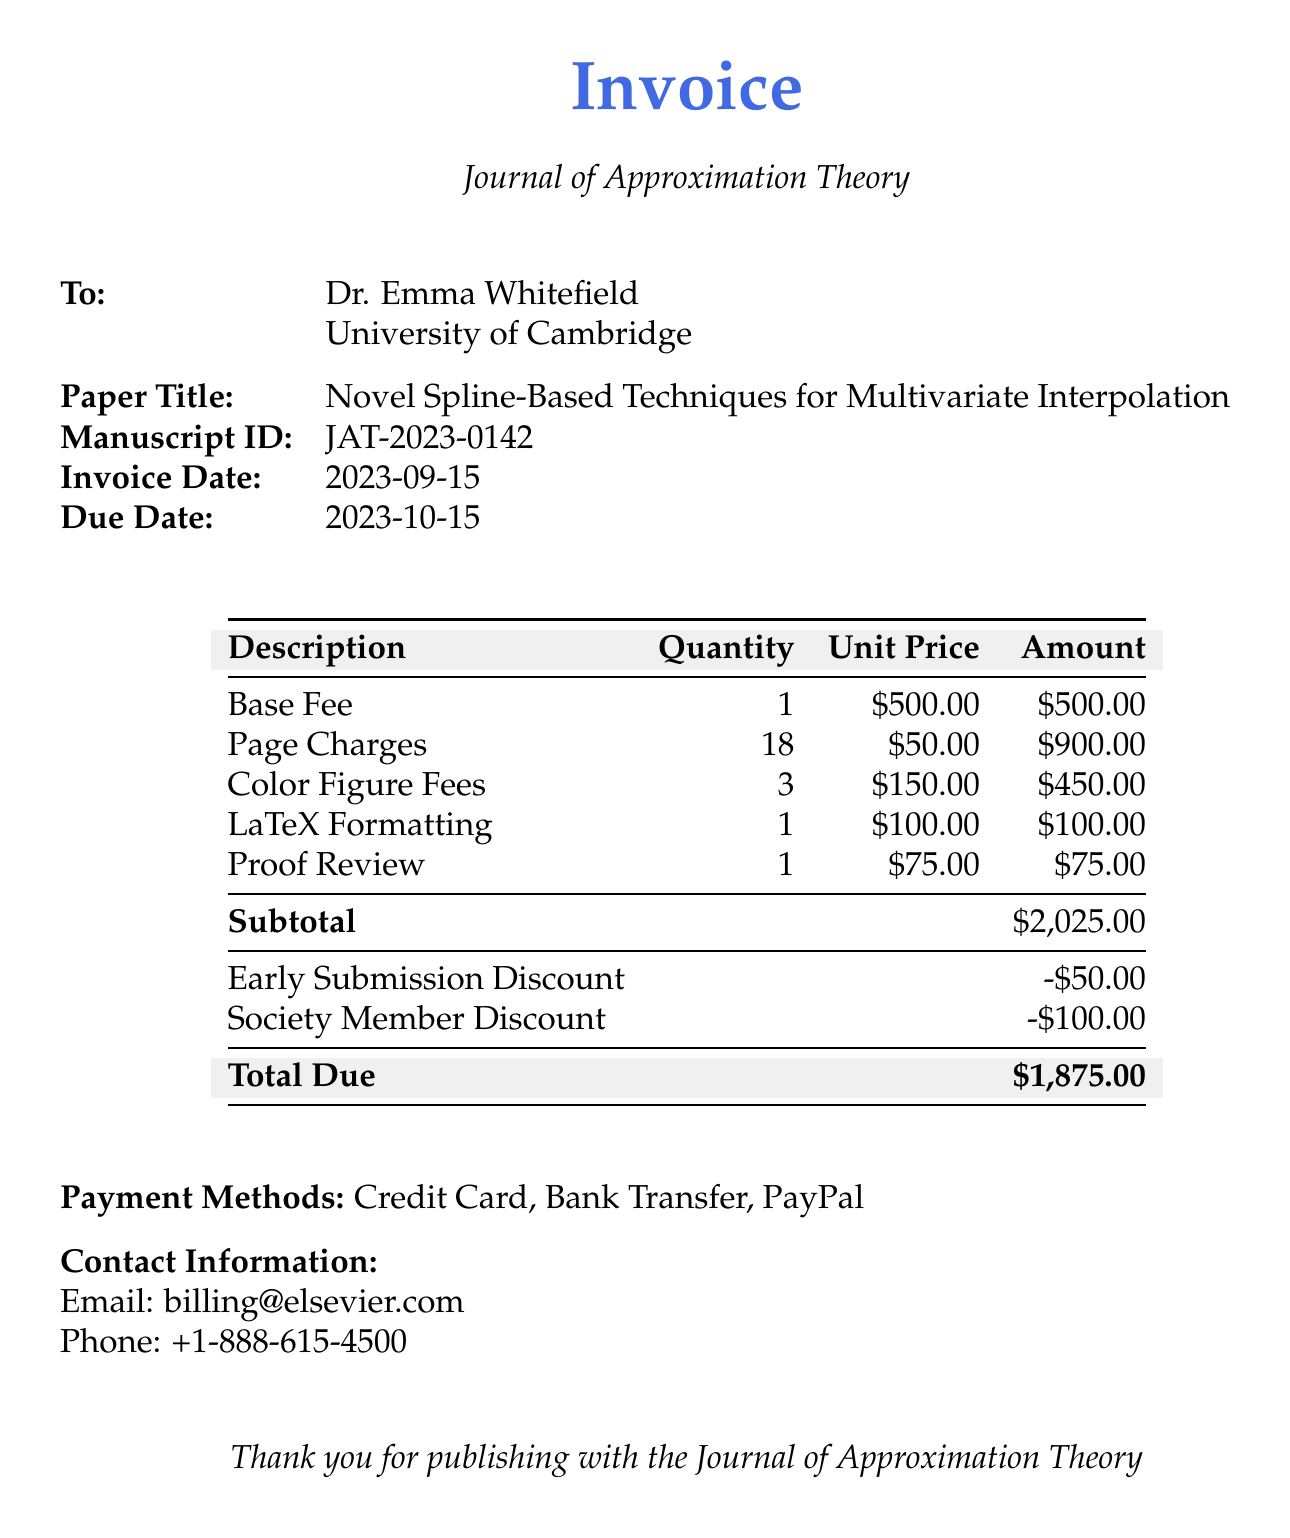What is the title of the paper? The title of the paper is listed in the invoice under "Paper Title".
Answer: Novel Spline-Based Techniques for Multivariate Interpolation What is the manuscript ID? The manuscript ID can be found among the details of the invoice.
Answer: JAT-2023-0142 What is the invoice date? The invoice date is specified in the document.
Answer: 2023-09-15 What is the total due amount? The total due amount appears at the end of the invoice in the "Total Due" section.
Answer: $1,875.00 How many color figures are included in the charges? The number of color figures charged is detailed in the table under "Color Figure Fees".
Answer: 3 What is the subtotal amount before discounts? The subtotal is given just before any discounts are applied in the invoice.
Answer: $2,025.00 How much is the early submission discount? The amount of the early submission discount is explicitly stated in the invoice.
Answer: -$50.00 What types of payment methods are accepted? Accepted payment methods are listed in the "Payment Methods" section.
Answer: Credit Card, Bank Transfer, PayPal Who is the invoice addressed to? The recipient's information is provided in the "To" section of the invoice.
Answer: Dr. Emma Whitefield 